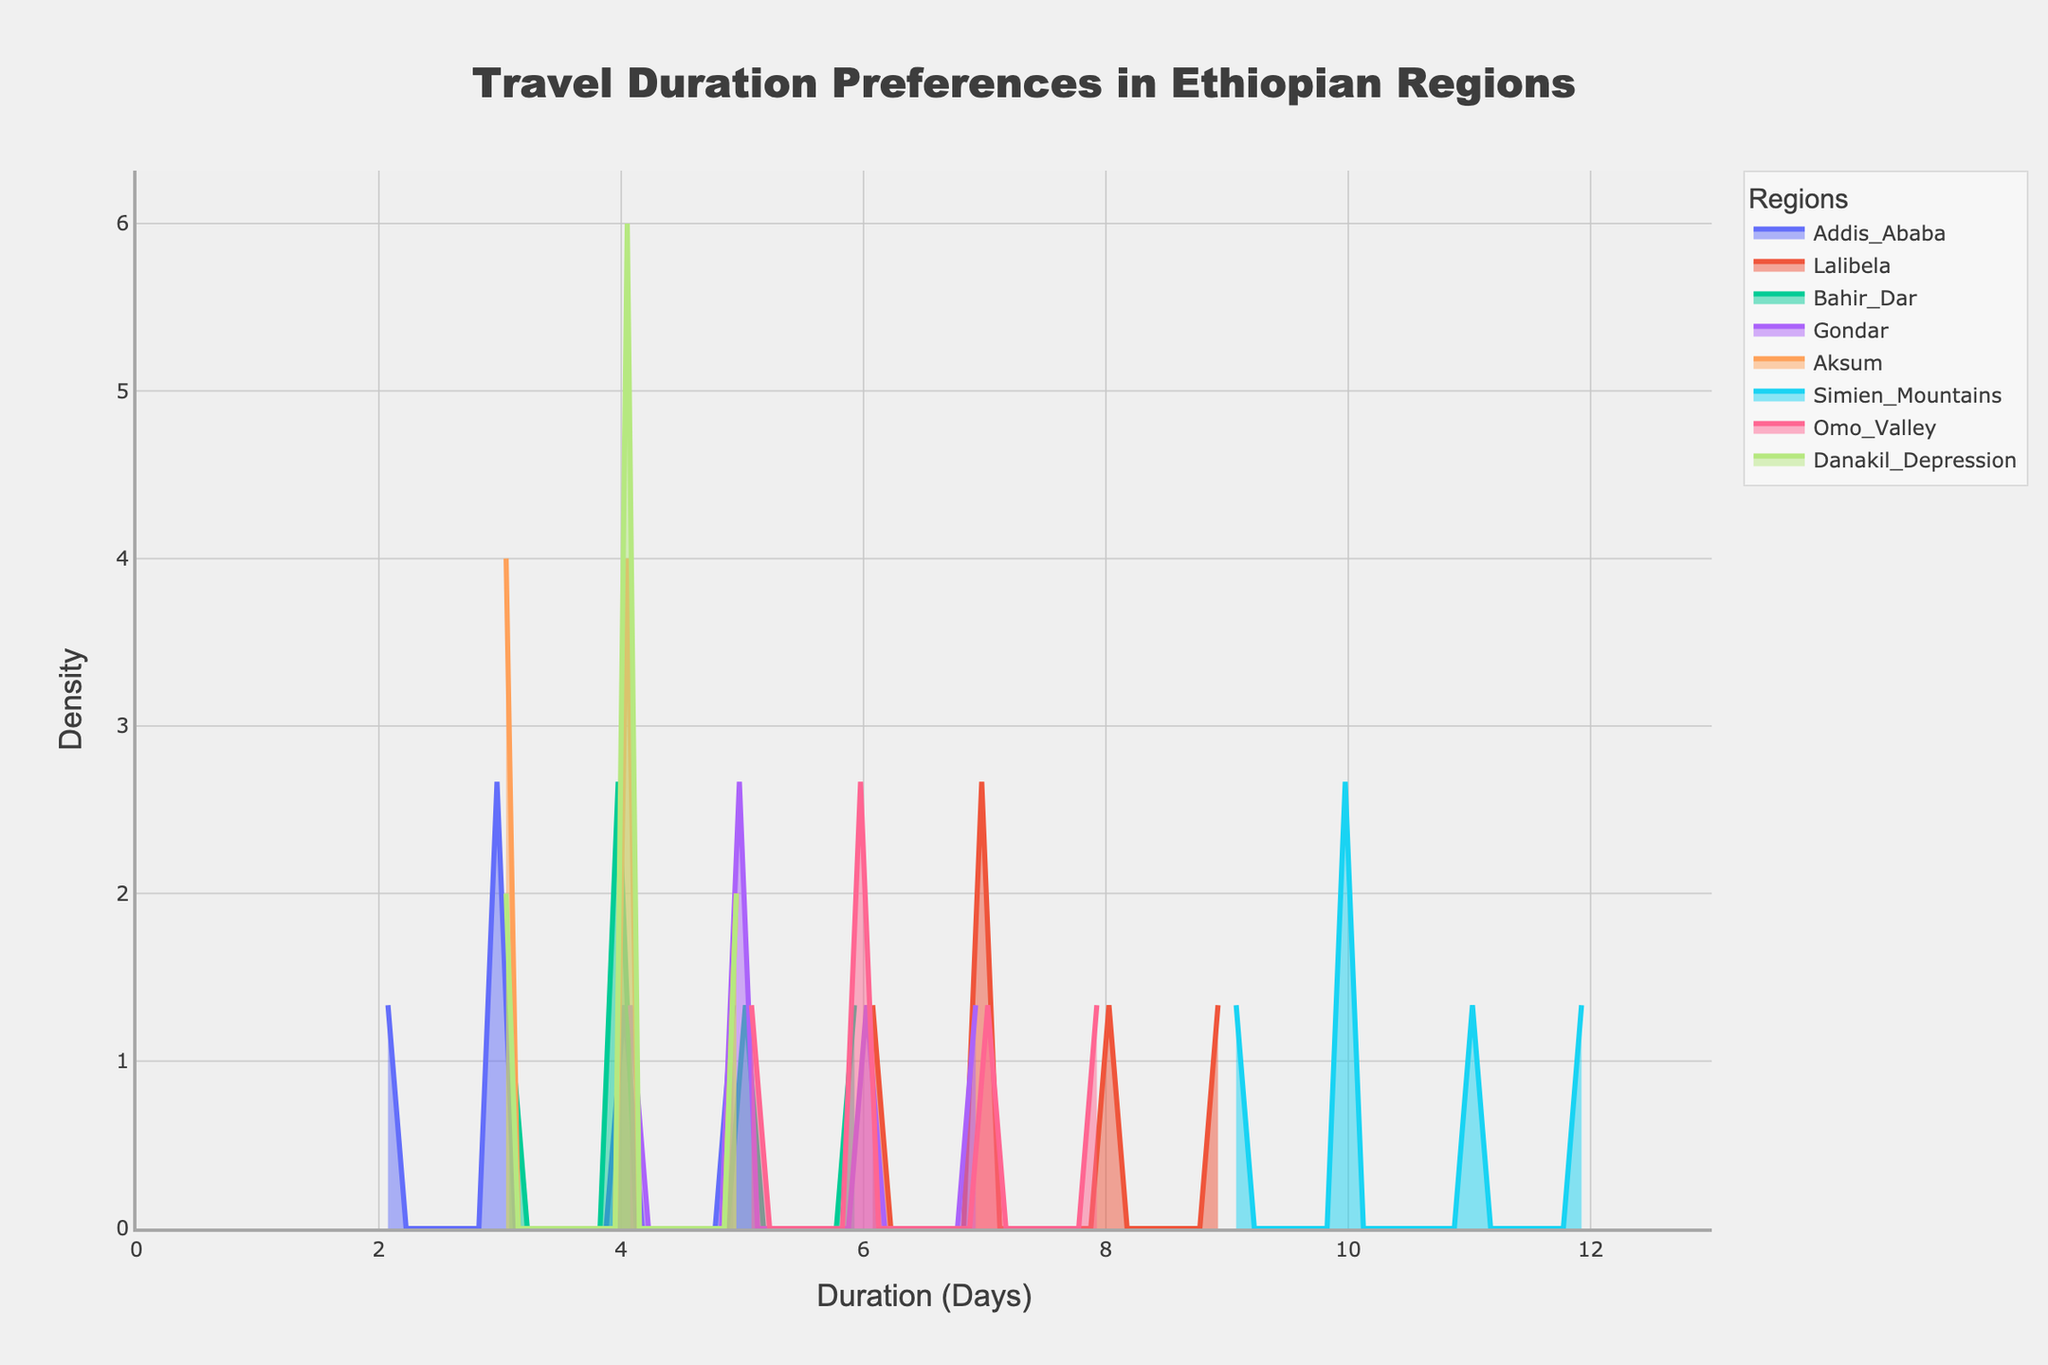What is the title of the figure? The title is typically displayed at the top of the figure. The title in this case is "Travel Duration Preferences in Ethiopian Regions"
Answer: Travel Duration Preferences in Ethiopian Regions Which region shows the highest density for longer travel durations? To determine the region with the highest density for longer travel durations, look for the region whose density curve peaks towards the right side of the x-axis, which represents days. The Simien Mountains show the highest density towards the longer travel durations.
Answer: Simien Mountains What is the range of travel durations shown on the x-axis? The x-axis represents the number of days, and the x-axis ticks typically start from the minimum value to the maximum value recorded in the data. In this case, the range is from 0 to the maximum duration plus 1.
Answer: 0 to 13 Which two regions have the most similar density distributions? Compare the shapes and peaks of the density curves for all regions to identify which two regions have curves that look the most alike. Addis Ababa and Bahir Dar have very similar density distributions, both peaking around the same travel duration.
Answer: Addis Ababa and Bahir Dar What is the peak travel duration for tourists visiting Gondar? The peak or mode of a density plot is the x-value where the density curve reaches its highest point. For Gondar, the peak travel duration is seen where its curve reaches the highest point.
Answer: 5 days Which region has the widest range of travel durations? The region with the widest range will have a curve that extends over the largest span of the x-axis. The Simien Mountains has data points from 9 to 12 days, giving it the widest range of travel durations.
Answer: Simien Mountains How does the travel duration preferences in Lalibela compare with those of Omo Valley? Compare the peaks and spread of the density curves for both regions. Lalibela has a relatively sharp peak around 7-9 days, whereas Omo Valley's curve shows a more distributed range around 5-8 days.
Answer: Lalibela peaks at 7-9 days, Omo Valley is more spread out around 5-8 days What is the density value for Simien Mountains at 10 days? Identify the height of the Simien Mountains' density curve at the 10 days mark on the x-axis. The curve reaches one of its peaks at this duration.
Answer: Highest point (exact numerical value not determinable without figure) Which region's density curve lies mostly to the left on the x-axis? The region with a density curve that lies to the left will have its peak and most of its area closer to the lower values on the x-axis. Addis Ababa's curve predominantly lies to the left, peaking around 3-5 days.
Answer: Addis Ababa 